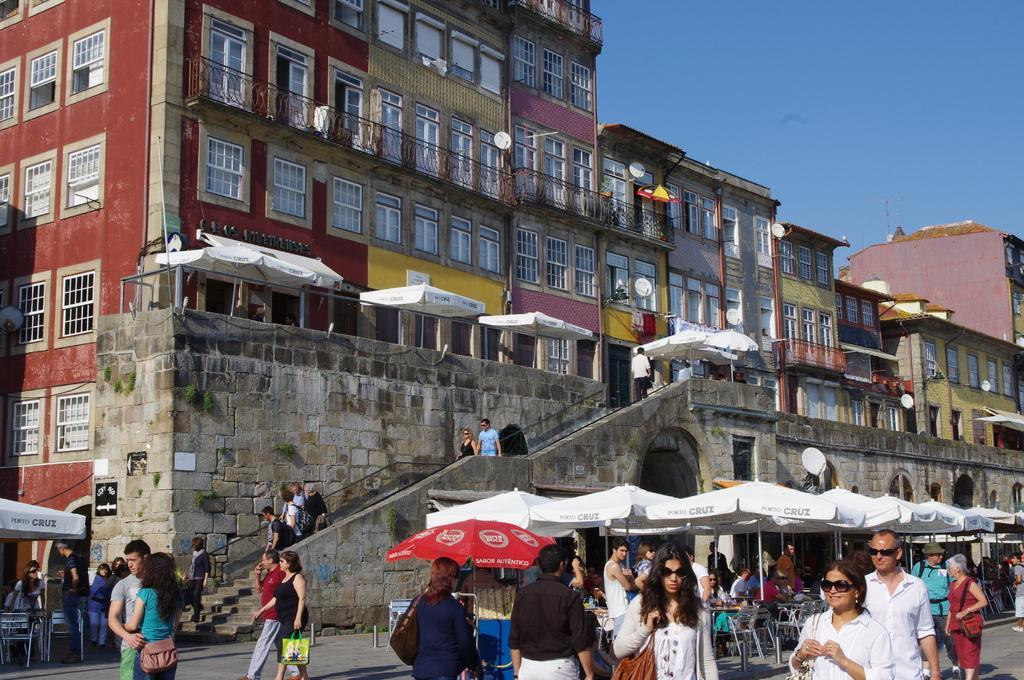How would you summarize this image in a sentence or two? In this image there are group of people standing , umbrellas to the poles, chairs, tables, buildings, antennas, sky. 